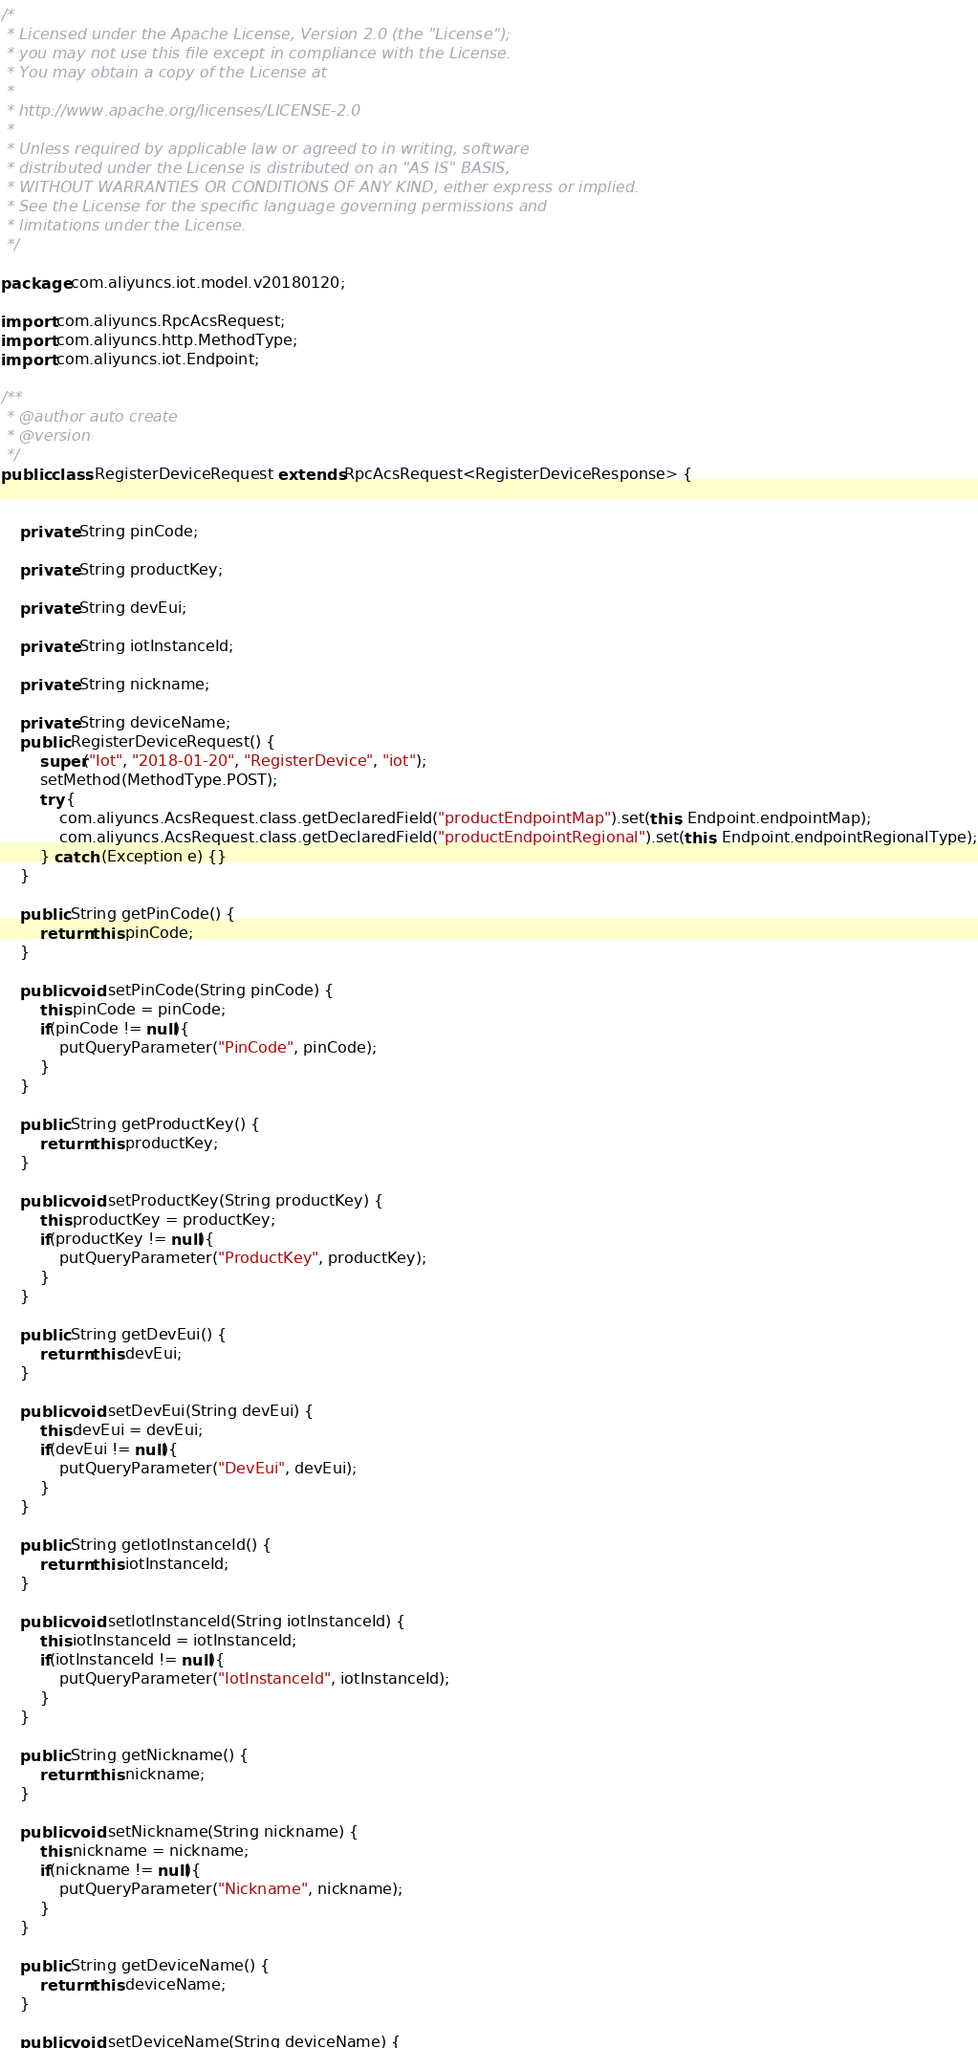<code> <loc_0><loc_0><loc_500><loc_500><_Java_>/*
 * Licensed under the Apache License, Version 2.0 (the "License");
 * you may not use this file except in compliance with the License.
 * You may obtain a copy of the License at
 *
 * http://www.apache.org/licenses/LICENSE-2.0
 *
 * Unless required by applicable law or agreed to in writing, software
 * distributed under the License is distributed on an "AS IS" BASIS,
 * WITHOUT WARRANTIES OR CONDITIONS OF ANY KIND, either express or implied.
 * See the License for the specific language governing permissions and
 * limitations under the License.
 */

package com.aliyuncs.iot.model.v20180120;

import com.aliyuncs.RpcAcsRequest;
import com.aliyuncs.http.MethodType;
import com.aliyuncs.iot.Endpoint;

/**
 * @author auto create
 * @version 
 */
public class RegisterDeviceRequest extends RpcAcsRequest<RegisterDeviceResponse> {
	   

	private String pinCode;

	private String productKey;

	private String devEui;

	private String iotInstanceId;

	private String nickname;

	private String deviceName;
	public RegisterDeviceRequest() {
		super("Iot", "2018-01-20", "RegisterDevice", "iot");
		setMethod(MethodType.POST);
		try {
			com.aliyuncs.AcsRequest.class.getDeclaredField("productEndpointMap").set(this, Endpoint.endpointMap);
			com.aliyuncs.AcsRequest.class.getDeclaredField("productEndpointRegional").set(this, Endpoint.endpointRegionalType);
		} catch (Exception e) {}
	}

	public String getPinCode() {
		return this.pinCode;
	}

	public void setPinCode(String pinCode) {
		this.pinCode = pinCode;
		if(pinCode != null){
			putQueryParameter("PinCode", pinCode);
		}
	}

	public String getProductKey() {
		return this.productKey;
	}

	public void setProductKey(String productKey) {
		this.productKey = productKey;
		if(productKey != null){
			putQueryParameter("ProductKey", productKey);
		}
	}

	public String getDevEui() {
		return this.devEui;
	}

	public void setDevEui(String devEui) {
		this.devEui = devEui;
		if(devEui != null){
			putQueryParameter("DevEui", devEui);
		}
	}

	public String getIotInstanceId() {
		return this.iotInstanceId;
	}

	public void setIotInstanceId(String iotInstanceId) {
		this.iotInstanceId = iotInstanceId;
		if(iotInstanceId != null){
			putQueryParameter("IotInstanceId", iotInstanceId);
		}
	}

	public String getNickname() {
		return this.nickname;
	}

	public void setNickname(String nickname) {
		this.nickname = nickname;
		if(nickname != null){
			putQueryParameter("Nickname", nickname);
		}
	}

	public String getDeviceName() {
		return this.deviceName;
	}

	public void setDeviceName(String deviceName) {</code> 